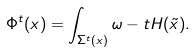Convert formula to latex. <formula><loc_0><loc_0><loc_500><loc_500>\Phi ^ { t } ( x ) = \int _ { \Sigma ^ { t } ( x ) } \omega - t H ( \tilde { x } ) .</formula> 